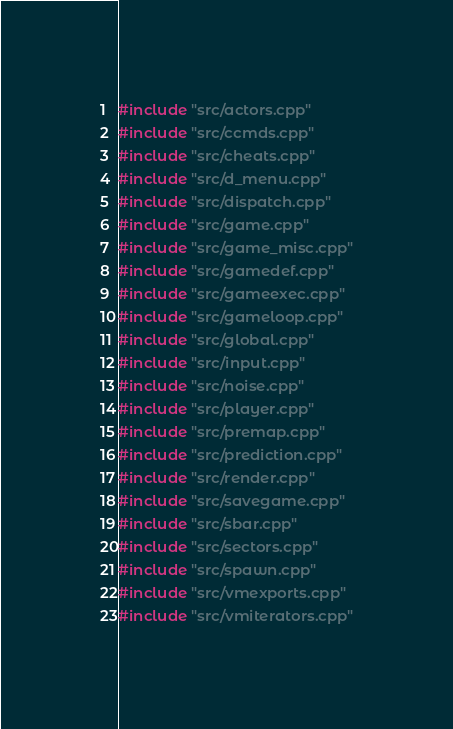<code> <loc_0><loc_0><loc_500><loc_500><_C++_>#include "src/actors.cpp"
#include "src/ccmds.cpp"
#include "src/cheats.cpp"
#include "src/d_menu.cpp"
#include "src/dispatch.cpp"
#include "src/game.cpp"
#include "src/game_misc.cpp"
#include "src/gamedef.cpp"
#include "src/gameexec.cpp"
#include "src/gameloop.cpp"
#include "src/global.cpp"
#include "src/input.cpp"
#include "src/noise.cpp"
#include "src/player.cpp"
#include "src/premap.cpp"
#include "src/prediction.cpp"
#include "src/render.cpp"
#include "src/savegame.cpp"
#include "src/sbar.cpp"
#include "src/sectors.cpp"
#include "src/spawn.cpp"
#include "src/vmexports.cpp"
#include "src/vmiterators.cpp"
</code> 